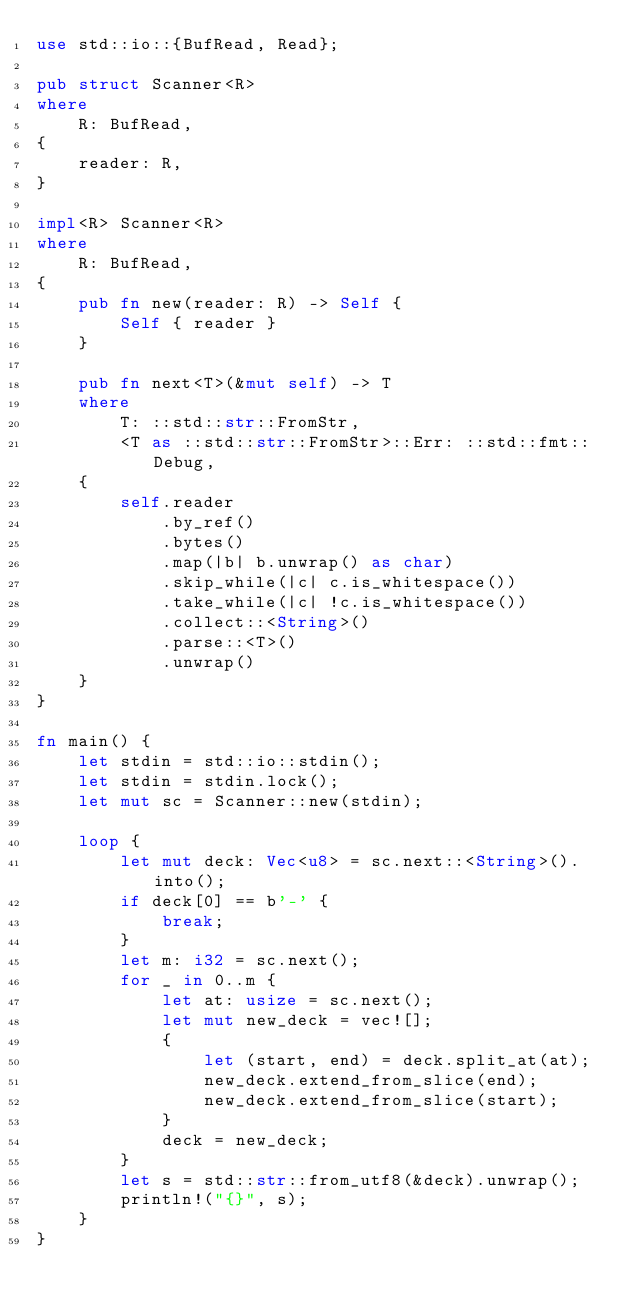Convert code to text. <code><loc_0><loc_0><loc_500><loc_500><_Rust_>use std::io::{BufRead, Read};

pub struct Scanner<R>
where
    R: BufRead,
{
    reader: R,
}

impl<R> Scanner<R>
where
    R: BufRead,
{
    pub fn new(reader: R) -> Self {
        Self { reader }
    }

    pub fn next<T>(&mut self) -> T
    where
        T: ::std::str::FromStr,
        <T as ::std::str::FromStr>::Err: ::std::fmt::Debug,
    {
        self.reader
            .by_ref()
            .bytes()
            .map(|b| b.unwrap() as char)
            .skip_while(|c| c.is_whitespace())
            .take_while(|c| !c.is_whitespace())
            .collect::<String>()
            .parse::<T>()
            .unwrap()
    }
}

fn main() {
    let stdin = std::io::stdin();
    let stdin = stdin.lock();
    let mut sc = Scanner::new(stdin);

    loop {
        let mut deck: Vec<u8> = sc.next::<String>().into();
        if deck[0] == b'-' {
            break;
        }
        let m: i32 = sc.next();
        for _ in 0..m {
            let at: usize = sc.next();
            let mut new_deck = vec![];
            {
                let (start, end) = deck.split_at(at);
                new_deck.extend_from_slice(end);
                new_deck.extend_from_slice(start);
            }
            deck = new_deck;
        }
        let s = std::str::from_utf8(&deck).unwrap();
        println!("{}", s);
    }
}

</code> 